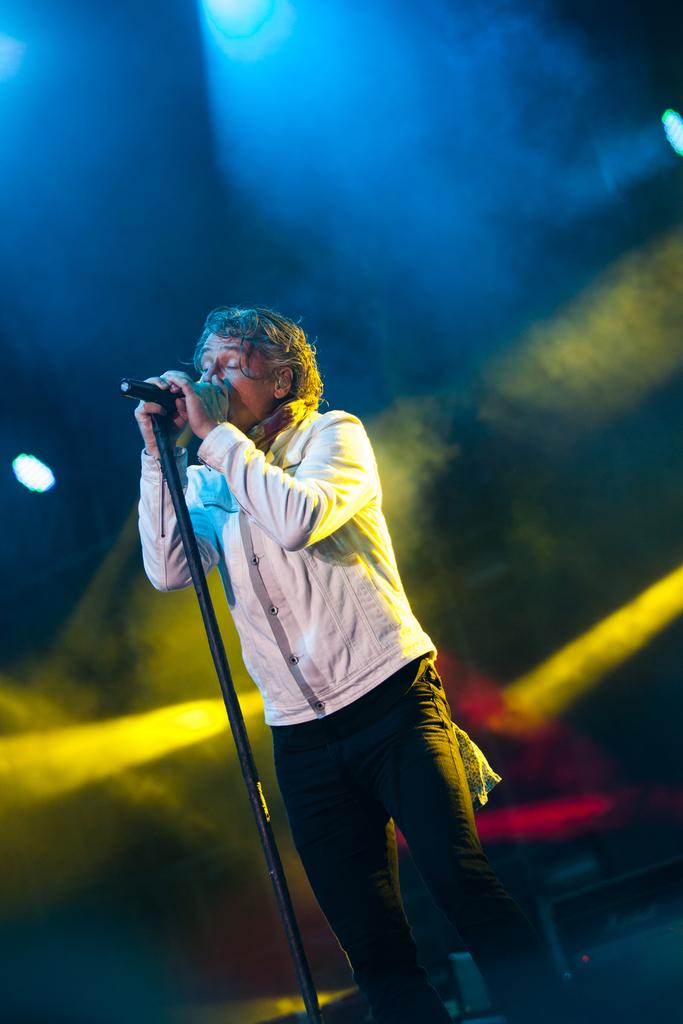What is the person in the image doing? The person is standing in the image and holding a mic. What is the mic attached to in the image? The mic is on a stand in the image. What can be seen in the background of the image? There are lights visible in the image. What type of fiction is the person reading to their daughter in the image? There is no indication in the image that the person is reading fiction or has a daughter present. 